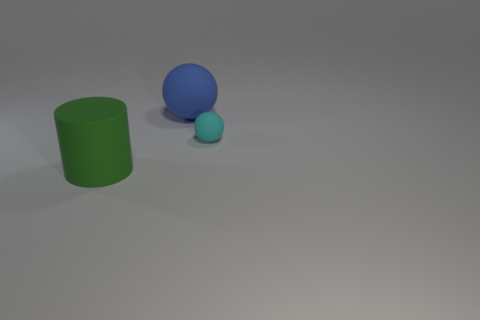What is the big green cylinder made of?
Offer a terse response. Rubber. Does the large blue matte object have the same shape as the cyan matte object?
Make the answer very short. Yes. Are there any big purple spheres made of the same material as the big cylinder?
Make the answer very short. No. There is a object that is right of the green cylinder and left of the cyan rubber object; what is its color?
Make the answer very short. Blue. Is there a cyan thing that has the same shape as the large blue thing?
Give a very brief answer. Yes. What number of other objects are there of the same shape as the large blue thing?
Your answer should be very brief. 1. There is a blue thing; is it the same shape as the matte thing to the right of the large blue rubber sphere?
Your answer should be very brief. Yes. What is the material of the tiny cyan object that is the same shape as the blue object?
Your answer should be compact. Rubber. What number of large things are either cyan shiny things or blue matte objects?
Keep it short and to the point. 1. Are there fewer cylinders behind the cyan rubber object than cylinders left of the blue thing?
Keep it short and to the point. Yes. 